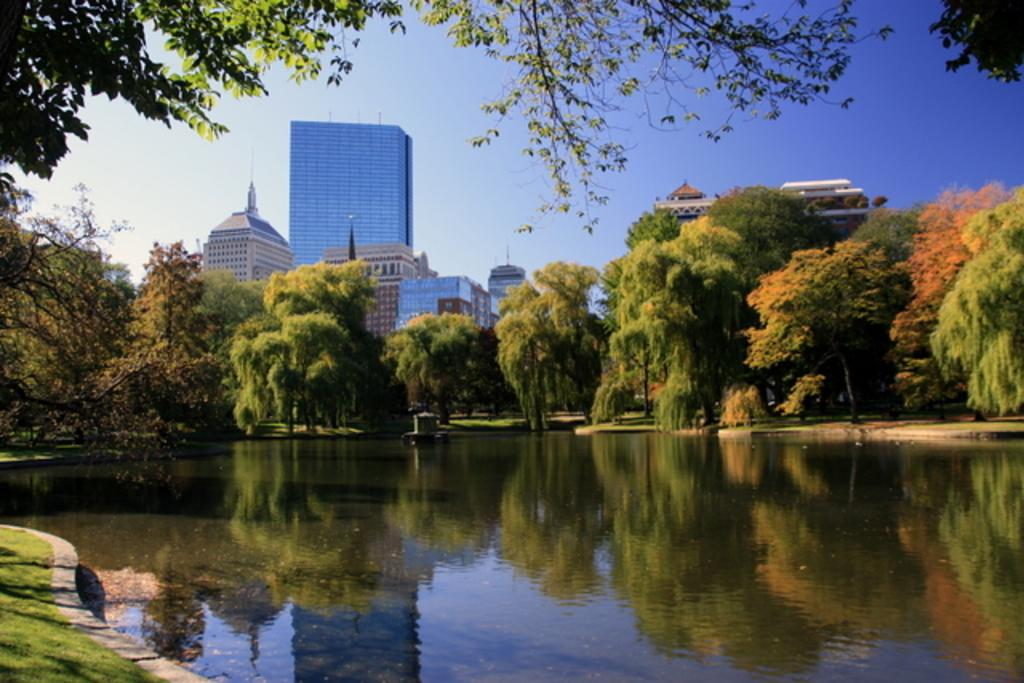What type of natural feature is present in the image? There is a lake in the image. What can be seen behind the lake? Trees are visible behind the lake. What else is visible in the background of the image? There are buildings in the background of the image. What part of the natural environment is visible in the image? The sky is visible in the image. What type of waste can be seen floating on the lake in the image? There is no waste visible in the image; the lake appears to be clear and free of debris. 